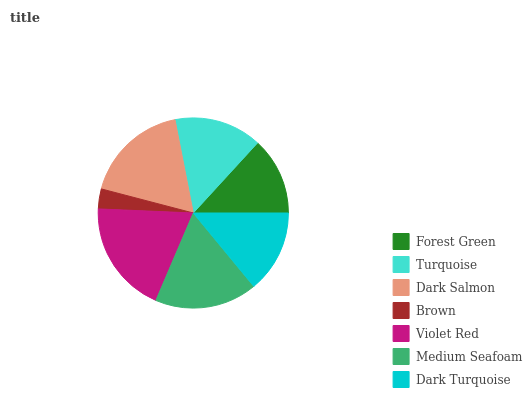Is Brown the minimum?
Answer yes or no. Yes. Is Violet Red the maximum?
Answer yes or no. Yes. Is Turquoise the minimum?
Answer yes or no. No. Is Turquoise the maximum?
Answer yes or no. No. Is Turquoise greater than Forest Green?
Answer yes or no. Yes. Is Forest Green less than Turquoise?
Answer yes or no. Yes. Is Forest Green greater than Turquoise?
Answer yes or no. No. Is Turquoise less than Forest Green?
Answer yes or no. No. Is Turquoise the high median?
Answer yes or no. Yes. Is Turquoise the low median?
Answer yes or no. Yes. Is Medium Seafoam the high median?
Answer yes or no. No. Is Medium Seafoam the low median?
Answer yes or no. No. 